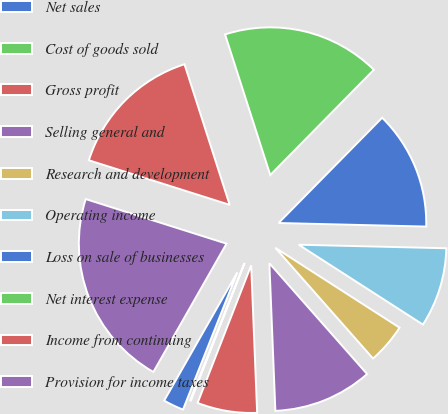<chart> <loc_0><loc_0><loc_500><loc_500><pie_chart><fcel>Net sales<fcel>Cost of goods sold<fcel>Gross profit<fcel>Selling general and<fcel>Research and development<fcel>Operating income<fcel>Loss on sale of businesses<fcel>Net interest expense<fcel>Income from continuing<fcel>Provision for income taxes<nl><fcel>2.25%<fcel>0.09%<fcel>6.55%<fcel>10.86%<fcel>4.4%<fcel>8.71%<fcel>13.01%<fcel>17.32%<fcel>15.17%<fcel>21.63%<nl></chart> 